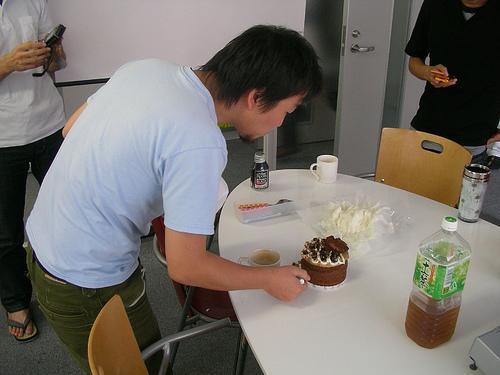How many cakes?
Give a very brief answer. 1. 